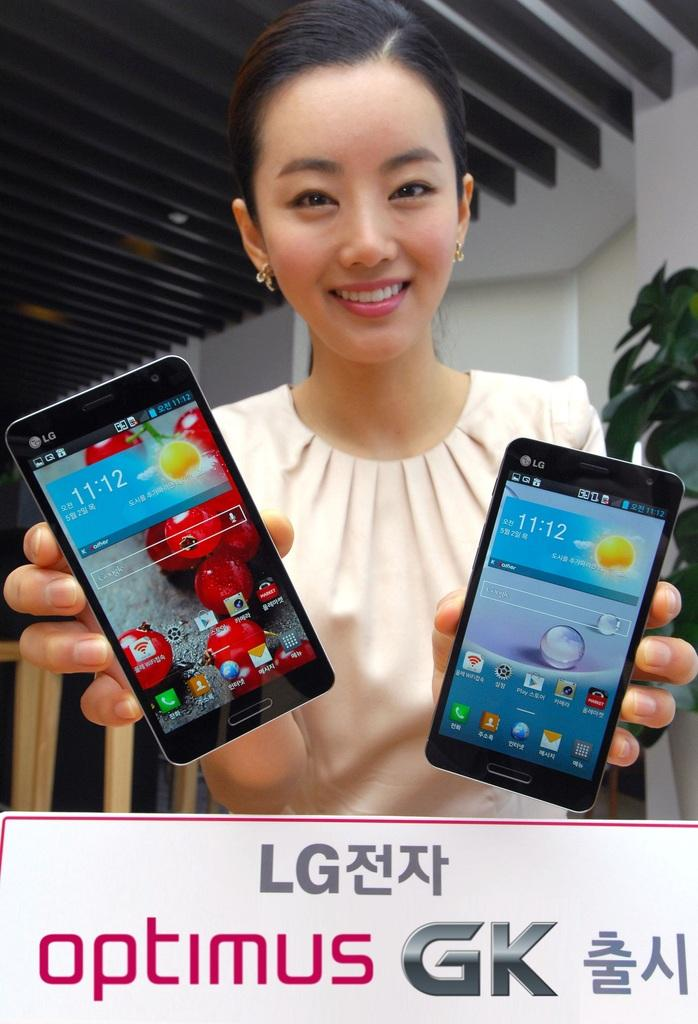<image>
Share a concise interpretation of the image provided. Both LG cellphones that the woman is holding display the time as 11:12. 